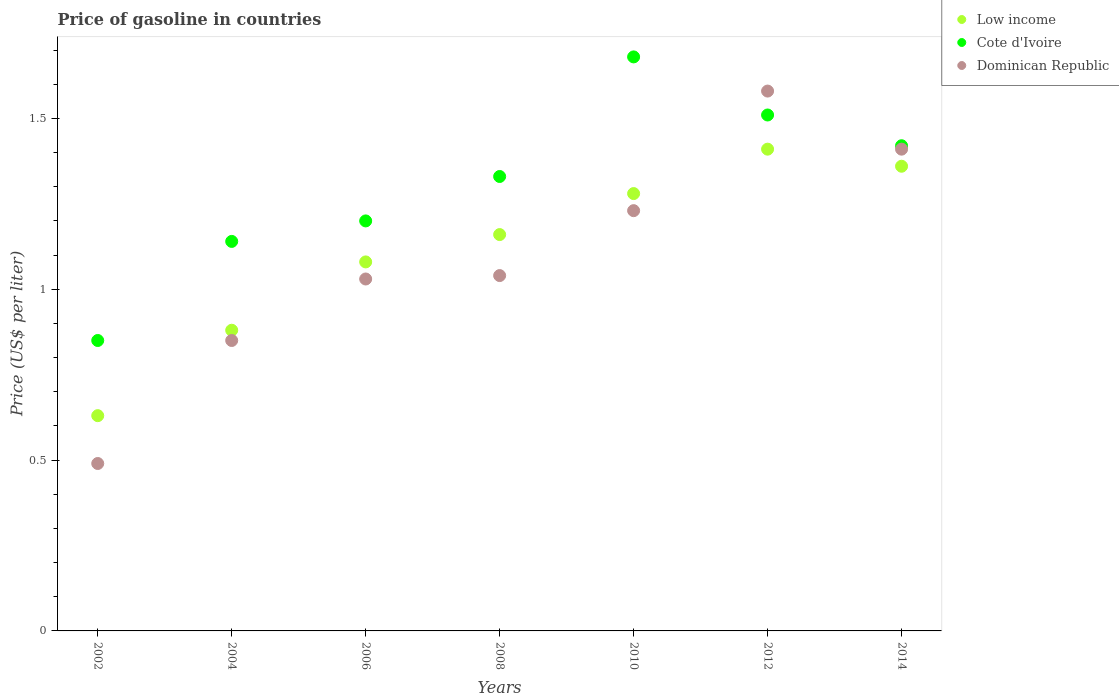What is the price of gasoline in Low income in 2012?
Ensure brevity in your answer.  1.41. Across all years, what is the maximum price of gasoline in Dominican Republic?
Offer a terse response. 1.58. Across all years, what is the minimum price of gasoline in Cote d'Ivoire?
Your response must be concise. 0.85. In which year was the price of gasoline in Dominican Republic minimum?
Keep it short and to the point. 2002. What is the total price of gasoline in Low income in the graph?
Ensure brevity in your answer.  7.8. What is the difference between the price of gasoline in Dominican Republic in 2006 and that in 2008?
Give a very brief answer. -0.01. What is the average price of gasoline in Low income per year?
Provide a succinct answer. 1.11. In the year 2008, what is the difference between the price of gasoline in Low income and price of gasoline in Cote d'Ivoire?
Keep it short and to the point. -0.17. In how many years, is the price of gasoline in Low income greater than 1.1 US$?
Offer a very short reply. 4. What is the ratio of the price of gasoline in Dominican Republic in 2004 to that in 2012?
Provide a short and direct response. 0.54. Is the difference between the price of gasoline in Low income in 2002 and 2014 greater than the difference between the price of gasoline in Cote d'Ivoire in 2002 and 2014?
Provide a short and direct response. No. What is the difference between the highest and the second highest price of gasoline in Dominican Republic?
Keep it short and to the point. 0.17. What is the difference between the highest and the lowest price of gasoline in Cote d'Ivoire?
Your response must be concise. 0.83. Is the sum of the price of gasoline in Low income in 2010 and 2014 greater than the maximum price of gasoline in Dominican Republic across all years?
Keep it short and to the point. Yes. Is it the case that in every year, the sum of the price of gasoline in Dominican Republic and price of gasoline in Cote d'Ivoire  is greater than the price of gasoline in Low income?
Make the answer very short. Yes. How many years are there in the graph?
Keep it short and to the point. 7. Does the graph contain grids?
Ensure brevity in your answer.  No. Where does the legend appear in the graph?
Ensure brevity in your answer.  Top right. How are the legend labels stacked?
Your answer should be compact. Vertical. What is the title of the graph?
Provide a short and direct response. Price of gasoline in countries. What is the label or title of the X-axis?
Your response must be concise. Years. What is the label or title of the Y-axis?
Your answer should be very brief. Price (US$ per liter). What is the Price (US$ per liter) in Low income in 2002?
Make the answer very short. 0.63. What is the Price (US$ per liter) of Cote d'Ivoire in 2002?
Provide a short and direct response. 0.85. What is the Price (US$ per liter) in Dominican Republic in 2002?
Give a very brief answer. 0.49. What is the Price (US$ per liter) in Cote d'Ivoire in 2004?
Provide a succinct answer. 1.14. What is the Price (US$ per liter) of Low income in 2006?
Your answer should be compact. 1.08. What is the Price (US$ per liter) of Dominican Republic in 2006?
Keep it short and to the point. 1.03. What is the Price (US$ per liter) in Low income in 2008?
Ensure brevity in your answer.  1.16. What is the Price (US$ per liter) of Cote d'Ivoire in 2008?
Your answer should be very brief. 1.33. What is the Price (US$ per liter) of Dominican Republic in 2008?
Provide a short and direct response. 1.04. What is the Price (US$ per liter) of Low income in 2010?
Offer a very short reply. 1.28. What is the Price (US$ per liter) in Cote d'Ivoire in 2010?
Your answer should be compact. 1.68. What is the Price (US$ per liter) in Dominican Republic in 2010?
Offer a very short reply. 1.23. What is the Price (US$ per liter) in Low income in 2012?
Offer a very short reply. 1.41. What is the Price (US$ per liter) in Cote d'Ivoire in 2012?
Offer a very short reply. 1.51. What is the Price (US$ per liter) in Dominican Republic in 2012?
Provide a succinct answer. 1.58. What is the Price (US$ per liter) in Low income in 2014?
Your answer should be compact. 1.36. What is the Price (US$ per liter) of Cote d'Ivoire in 2014?
Your response must be concise. 1.42. What is the Price (US$ per liter) of Dominican Republic in 2014?
Provide a short and direct response. 1.41. Across all years, what is the maximum Price (US$ per liter) in Low income?
Make the answer very short. 1.41. Across all years, what is the maximum Price (US$ per liter) in Cote d'Ivoire?
Provide a succinct answer. 1.68. Across all years, what is the maximum Price (US$ per liter) in Dominican Republic?
Provide a short and direct response. 1.58. Across all years, what is the minimum Price (US$ per liter) of Low income?
Your answer should be very brief. 0.63. Across all years, what is the minimum Price (US$ per liter) of Dominican Republic?
Ensure brevity in your answer.  0.49. What is the total Price (US$ per liter) of Cote d'Ivoire in the graph?
Your answer should be compact. 9.13. What is the total Price (US$ per liter) of Dominican Republic in the graph?
Ensure brevity in your answer.  7.63. What is the difference between the Price (US$ per liter) of Cote d'Ivoire in 2002 and that in 2004?
Give a very brief answer. -0.29. What is the difference between the Price (US$ per liter) of Dominican Republic in 2002 and that in 2004?
Your response must be concise. -0.36. What is the difference between the Price (US$ per liter) of Low income in 2002 and that in 2006?
Provide a succinct answer. -0.45. What is the difference between the Price (US$ per liter) of Cote d'Ivoire in 2002 and that in 2006?
Make the answer very short. -0.35. What is the difference between the Price (US$ per liter) of Dominican Republic in 2002 and that in 2006?
Your answer should be compact. -0.54. What is the difference between the Price (US$ per liter) in Low income in 2002 and that in 2008?
Offer a terse response. -0.53. What is the difference between the Price (US$ per liter) of Cote d'Ivoire in 2002 and that in 2008?
Your answer should be very brief. -0.48. What is the difference between the Price (US$ per liter) in Dominican Republic in 2002 and that in 2008?
Offer a terse response. -0.55. What is the difference between the Price (US$ per liter) in Low income in 2002 and that in 2010?
Offer a very short reply. -0.65. What is the difference between the Price (US$ per liter) of Cote d'Ivoire in 2002 and that in 2010?
Give a very brief answer. -0.83. What is the difference between the Price (US$ per liter) in Dominican Republic in 2002 and that in 2010?
Make the answer very short. -0.74. What is the difference between the Price (US$ per liter) in Low income in 2002 and that in 2012?
Offer a terse response. -0.78. What is the difference between the Price (US$ per liter) of Cote d'Ivoire in 2002 and that in 2012?
Offer a terse response. -0.66. What is the difference between the Price (US$ per liter) of Dominican Republic in 2002 and that in 2012?
Your answer should be compact. -1.09. What is the difference between the Price (US$ per liter) in Low income in 2002 and that in 2014?
Provide a succinct answer. -0.73. What is the difference between the Price (US$ per liter) in Cote d'Ivoire in 2002 and that in 2014?
Give a very brief answer. -0.57. What is the difference between the Price (US$ per liter) of Dominican Republic in 2002 and that in 2014?
Ensure brevity in your answer.  -0.92. What is the difference between the Price (US$ per liter) of Low income in 2004 and that in 2006?
Provide a short and direct response. -0.2. What is the difference between the Price (US$ per liter) of Cote d'Ivoire in 2004 and that in 2006?
Your response must be concise. -0.06. What is the difference between the Price (US$ per liter) of Dominican Republic in 2004 and that in 2006?
Provide a short and direct response. -0.18. What is the difference between the Price (US$ per liter) in Low income in 2004 and that in 2008?
Offer a very short reply. -0.28. What is the difference between the Price (US$ per liter) of Cote d'Ivoire in 2004 and that in 2008?
Your answer should be compact. -0.19. What is the difference between the Price (US$ per liter) in Dominican Republic in 2004 and that in 2008?
Provide a short and direct response. -0.19. What is the difference between the Price (US$ per liter) in Low income in 2004 and that in 2010?
Offer a very short reply. -0.4. What is the difference between the Price (US$ per liter) of Cote d'Ivoire in 2004 and that in 2010?
Give a very brief answer. -0.54. What is the difference between the Price (US$ per liter) in Dominican Republic in 2004 and that in 2010?
Offer a terse response. -0.38. What is the difference between the Price (US$ per liter) of Low income in 2004 and that in 2012?
Offer a terse response. -0.53. What is the difference between the Price (US$ per liter) in Cote d'Ivoire in 2004 and that in 2012?
Ensure brevity in your answer.  -0.37. What is the difference between the Price (US$ per liter) of Dominican Republic in 2004 and that in 2012?
Your answer should be very brief. -0.73. What is the difference between the Price (US$ per liter) of Low income in 2004 and that in 2014?
Give a very brief answer. -0.48. What is the difference between the Price (US$ per liter) in Cote d'Ivoire in 2004 and that in 2014?
Offer a very short reply. -0.28. What is the difference between the Price (US$ per liter) of Dominican Republic in 2004 and that in 2014?
Give a very brief answer. -0.56. What is the difference between the Price (US$ per liter) of Low income in 2006 and that in 2008?
Your answer should be compact. -0.08. What is the difference between the Price (US$ per liter) in Cote d'Ivoire in 2006 and that in 2008?
Offer a very short reply. -0.13. What is the difference between the Price (US$ per liter) in Dominican Republic in 2006 and that in 2008?
Offer a very short reply. -0.01. What is the difference between the Price (US$ per liter) in Low income in 2006 and that in 2010?
Make the answer very short. -0.2. What is the difference between the Price (US$ per liter) in Cote d'Ivoire in 2006 and that in 2010?
Your answer should be compact. -0.48. What is the difference between the Price (US$ per liter) of Dominican Republic in 2006 and that in 2010?
Give a very brief answer. -0.2. What is the difference between the Price (US$ per liter) of Low income in 2006 and that in 2012?
Give a very brief answer. -0.33. What is the difference between the Price (US$ per liter) in Cote d'Ivoire in 2006 and that in 2012?
Provide a short and direct response. -0.31. What is the difference between the Price (US$ per liter) of Dominican Republic in 2006 and that in 2012?
Ensure brevity in your answer.  -0.55. What is the difference between the Price (US$ per liter) of Low income in 2006 and that in 2014?
Offer a very short reply. -0.28. What is the difference between the Price (US$ per liter) in Cote d'Ivoire in 2006 and that in 2014?
Offer a very short reply. -0.22. What is the difference between the Price (US$ per liter) in Dominican Republic in 2006 and that in 2014?
Offer a very short reply. -0.38. What is the difference between the Price (US$ per liter) in Low income in 2008 and that in 2010?
Offer a very short reply. -0.12. What is the difference between the Price (US$ per liter) in Cote d'Ivoire in 2008 and that in 2010?
Your answer should be compact. -0.35. What is the difference between the Price (US$ per liter) in Dominican Republic in 2008 and that in 2010?
Your answer should be very brief. -0.19. What is the difference between the Price (US$ per liter) of Low income in 2008 and that in 2012?
Ensure brevity in your answer.  -0.25. What is the difference between the Price (US$ per liter) of Cote d'Ivoire in 2008 and that in 2012?
Your answer should be very brief. -0.18. What is the difference between the Price (US$ per liter) in Dominican Republic in 2008 and that in 2012?
Offer a terse response. -0.54. What is the difference between the Price (US$ per liter) in Cote d'Ivoire in 2008 and that in 2014?
Make the answer very short. -0.09. What is the difference between the Price (US$ per liter) of Dominican Republic in 2008 and that in 2014?
Give a very brief answer. -0.37. What is the difference between the Price (US$ per liter) of Low income in 2010 and that in 2012?
Provide a succinct answer. -0.13. What is the difference between the Price (US$ per liter) of Cote d'Ivoire in 2010 and that in 2012?
Make the answer very short. 0.17. What is the difference between the Price (US$ per liter) in Dominican Republic in 2010 and that in 2012?
Provide a succinct answer. -0.35. What is the difference between the Price (US$ per liter) in Low income in 2010 and that in 2014?
Ensure brevity in your answer.  -0.08. What is the difference between the Price (US$ per liter) in Cote d'Ivoire in 2010 and that in 2014?
Give a very brief answer. 0.26. What is the difference between the Price (US$ per liter) in Dominican Republic in 2010 and that in 2014?
Ensure brevity in your answer.  -0.18. What is the difference between the Price (US$ per liter) of Low income in 2012 and that in 2014?
Ensure brevity in your answer.  0.05. What is the difference between the Price (US$ per liter) in Cote d'Ivoire in 2012 and that in 2014?
Ensure brevity in your answer.  0.09. What is the difference between the Price (US$ per liter) of Dominican Republic in 2012 and that in 2014?
Ensure brevity in your answer.  0.17. What is the difference between the Price (US$ per liter) of Low income in 2002 and the Price (US$ per liter) of Cote d'Ivoire in 2004?
Provide a succinct answer. -0.51. What is the difference between the Price (US$ per liter) in Low income in 2002 and the Price (US$ per liter) in Dominican Republic in 2004?
Offer a very short reply. -0.22. What is the difference between the Price (US$ per liter) in Cote d'Ivoire in 2002 and the Price (US$ per liter) in Dominican Republic in 2004?
Your answer should be very brief. 0. What is the difference between the Price (US$ per liter) in Low income in 2002 and the Price (US$ per liter) in Cote d'Ivoire in 2006?
Give a very brief answer. -0.57. What is the difference between the Price (US$ per liter) of Cote d'Ivoire in 2002 and the Price (US$ per liter) of Dominican Republic in 2006?
Your answer should be compact. -0.18. What is the difference between the Price (US$ per liter) in Low income in 2002 and the Price (US$ per liter) in Cote d'Ivoire in 2008?
Give a very brief answer. -0.7. What is the difference between the Price (US$ per liter) in Low income in 2002 and the Price (US$ per liter) in Dominican Republic in 2008?
Offer a terse response. -0.41. What is the difference between the Price (US$ per liter) of Cote d'Ivoire in 2002 and the Price (US$ per liter) of Dominican Republic in 2008?
Provide a succinct answer. -0.19. What is the difference between the Price (US$ per liter) of Low income in 2002 and the Price (US$ per liter) of Cote d'Ivoire in 2010?
Your response must be concise. -1.05. What is the difference between the Price (US$ per liter) in Low income in 2002 and the Price (US$ per liter) in Dominican Republic in 2010?
Make the answer very short. -0.6. What is the difference between the Price (US$ per liter) of Cote d'Ivoire in 2002 and the Price (US$ per liter) of Dominican Republic in 2010?
Ensure brevity in your answer.  -0.38. What is the difference between the Price (US$ per liter) of Low income in 2002 and the Price (US$ per liter) of Cote d'Ivoire in 2012?
Provide a short and direct response. -0.88. What is the difference between the Price (US$ per liter) in Low income in 2002 and the Price (US$ per liter) in Dominican Republic in 2012?
Make the answer very short. -0.95. What is the difference between the Price (US$ per liter) in Cote d'Ivoire in 2002 and the Price (US$ per liter) in Dominican Republic in 2012?
Ensure brevity in your answer.  -0.73. What is the difference between the Price (US$ per liter) in Low income in 2002 and the Price (US$ per liter) in Cote d'Ivoire in 2014?
Offer a very short reply. -0.79. What is the difference between the Price (US$ per liter) in Low income in 2002 and the Price (US$ per liter) in Dominican Republic in 2014?
Your answer should be very brief. -0.78. What is the difference between the Price (US$ per liter) of Cote d'Ivoire in 2002 and the Price (US$ per liter) of Dominican Republic in 2014?
Give a very brief answer. -0.56. What is the difference between the Price (US$ per liter) of Low income in 2004 and the Price (US$ per liter) of Cote d'Ivoire in 2006?
Give a very brief answer. -0.32. What is the difference between the Price (US$ per liter) of Cote d'Ivoire in 2004 and the Price (US$ per liter) of Dominican Republic in 2006?
Offer a terse response. 0.11. What is the difference between the Price (US$ per liter) in Low income in 2004 and the Price (US$ per liter) in Cote d'Ivoire in 2008?
Your answer should be very brief. -0.45. What is the difference between the Price (US$ per liter) of Low income in 2004 and the Price (US$ per liter) of Dominican Republic in 2008?
Ensure brevity in your answer.  -0.16. What is the difference between the Price (US$ per liter) of Low income in 2004 and the Price (US$ per liter) of Cote d'Ivoire in 2010?
Provide a short and direct response. -0.8. What is the difference between the Price (US$ per liter) of Low income in 2004 and the Price (US$ per liter) of Dominican Republic in 2010?
Keep it short and to the point. -0.35. What is the difference between the Price (US$ per liter) of Cote d'Ivoire in 2004 and the Price (US$ per liter) of Dominican Republic in 2010?
Keep it short and to the point. -0.09. What is the difference between the Price (US$ per liter) of Low income in 2004 and the Price (US$ per liter) of Cote d'Ivoire in 2012?
Your answer should be compact. -0.63. What is the difference between the Price (US$ per liter) of Cote d'Ivoire in 2004 and the Price (US$ per liter) of Dominican Republic in 2012?
Provide a short and direct response. -0.44. What is the difference between the Price (US$ per liter) of Low income in 2004 and the Price (US$ per liter) of Cote d'Ivoire in 2014?
Keep it short and to the point. -0.54. What is the difference between the Price (US$ per liter) in Low income in 2004 and the Price (US$ per liter) in Dominican Republic in 2014?
Give a very brief answer. -0.53. What is the difference between the Price (US$ per liter) of Cote d'Ivoire in 2004 and the Price (US$ per liter) of Dominican Republic in 2014?
Your answer should be very brief. -0.27. What is the difference between the Price (US$ per liter) of Cote d'Ivoire in 2006 and the Price (US$ per liter) of Dominican Republic in 2008?
Ensure brevity in your answer.  0.16. What is the difference between the Price (US$ per liter) of Cote d'Ivoire in 2006 and the Price (US$ per liter) of Dominican Republic in 2010?
Offer a very short reply. -0.03. What is the difference between the Price (US$ per liter) in Low income in 2006 and the Price (US$ per liter) in Cote d'Ivoire in 2012?
Offer a terse response. -0.43. What is the difference between the Price (US$ per liter) of Cote d'Ivoire in 2006 and the Price (US$ per liter) of Dominican Republic in 2012?
Give a very brief answer. -0.38. What is the difference between the Price (US$ per liter) of Low income in 2006 and the Price (US$ per liter) of Cote d'Ivoire in 2014?
Give a very brief answer. -0.34. What is the difference between the Price (US$ per liter) of Low income in 2006 and the Price (US$ per liter) of Dominican Republic in 2014?
Offer a very short reply. -0.33. What is the difference between the Price (US$ per liter) of Cote d'Ivoire in 2006 and the Price (US$ per liter) of Dominican Republic in 2014?
Your answer should be compact. -0.21. What is the difference between the Price (US$ per liter) in Low income in 2008 and the Price (US$ per liter) in Cote d'Ivoire in 2010?
Your answer should be very brief. -0.52. What is the difference between the Price (US$ per liter) in Low income in 2008 and the Price (US$ per liter) in Dominican Republic in 2010?
Keep it short and to the point. -0.07. What is the difference between the Price (US$ per liter) of Cote d'Ivoire in 2008 and the Price (US$ per liter) of Dominican Republic in 2010?
Your response must be concise. 0.1. What is the difference between the Price (US$ per liter) of Low income in 2008 and the Price (US$ per liter) of Cote d'Ivoire in 2012?
Your response must be concise. -0.35. What is the difference between the Price (US$ per liter) in Low income in 2008 and the Price (US$ per liter) in Dominican Republic in 2012?
Your response must be concise. -0.42. What is the difference between the Price (US$ per liter) in Low income in 2008 and the Price (US$ per liter) in Cote d'Ivoire in 2014?
Your answer should be very brief. -0.26. What is the difference between the Price (US$ per liter) of Cote d'Ivoire in 2008 and the Price (US$ per liter) of Dominican Republic in 2014?
Give a very brief answer. -0.08. What is the difference between the Price (US$ per liter) in Low income in 2010 and the Price (US$ per liter) in Cote d'Ivoire in 2012?
Ensure brevity in your answer.  -0.23. What is the difference between the Price (US$ per liter) in Low income in 2010 and the Price (US$ per liter) in Dominican Republic in 2012?
Make the answer very short. -0.3. What is the difference between the Price (US$ per liter) of Low income in 2010 and the Price (US$ per liter) of Cote d'Ivoire in 2014?
Keep it short and to the point. -0.14. What is the difference between the Price (US$ per liter) in Low income in 2010 and the Price (US$ per liter) in Dominican Republic in 2014?
Give a very brief answer. -0.13. What is the difference between the Price (US$ per liter) of Cote d'Ivoire in 2010 and the Price (US$ per liter) of Dominican Republic in 2014?
Your answer should be very brief. 0.27. What is the difference between the Price (US$ per liter) of Low income in 2012 and the Price (US$ per liter) of Cote d'Ivoire in 2014?
Offer a terse response. -0.01. What is the difference between the Price (US$ per liter) of Cote d'Ivoire in 2012 and the Price (US$ per liter) of Dominican Republic in 2014?
Offer a terse response. 0.1. What is the average Price (US$ per liter) of Low income per year?
Offer a terse response. 1.11. What is the average Price (US$ per liter) of Cote d'Ivoire per year?
Keep it short and to the point. 1.3. What is the average Price (US$ per liter) in Dominican Republic per year?
Provide a succinct answer. 1.09. In the year 2002, what is the difference between the Price (US$ per liter) in Low income and Price (US$ per liter) in Cote d'Ivoire?
Make the answer very short. -0.22. In the year 2002, what is the difference between the Price (US$ per liter) of Low income and Price (US$ per liter) of Dominican Republic?
Give a very brief answer. 0.14. In the year 2002, what is the difference between the Price (US$ per liter) in Cote d'Ivoire and Price (US$ per liter) in Dominican Republic?
Your response must be concise. 0.36. In the year 2004, what is the difference between the Price (US$ per liter) of Low income and Price (US$ per liter) of Cote d'Ivoire?
Your response must be concise. -0.26. In the year 2004, what is the difference between the Price (US$ per liter) in Low income and Price (US$ per liter) in Dominican Republic?
Your response must be concise. 0.03. In the year 2004, what is the difference between the Price (US$ per liter) of Cote d'Ivoire and Price (US$ per liter) of Dominican Republic?
Offer a terse response. 0.29. In the year 2006, what is the difference between the Price (US$ per liter) of Low income and Price (US$ per liter) of Cote d'Ivoire?
Provide a succinct answer. -0.12. In the year 2006, what is the difference between the Price (US$ per liter) of Low income and Price (US$ per liter) of Dominican Republic?
Keep it short and to the point. 0.05. In the year 2006, what is the difference between the Price (US$ per liter) in Cote d'Ivoire and Price (US$ per liter) in Dominican Republic?
Your answer should be compact. 0.17. In the year 2008, what is the difference between the Price (US$ per liter) in Low income and Price (US$ per liter) in Cote d'Ivoire?
Give a very brief answer. -0.17. In the year 2008, what is the difference between the Price (US$ per liter) in Low income and Price (US$ per liter) in Dominican Republic?
Make the answer very short. 0.12. In the year 2008, what is the difference between the Price (US$ per liter) of Cote d'Ivoire and Price (US$ per liter) of Dominican Republic?
Offer a terse response. 0.29. In the year 2010, what is the difference between the Price (US$ per liter) of Low income and Price (US$ per liter) of Cote d'Ivoire?
Keep it short and to the point. -0.4. In the year 2010, what is the difference between the Price (US$ per liter) in Low income and Price (US$ per liter) in Dominican Republic?
Provide a short and direct response. 0.05. In the year 2010, what is the difference between the Price (US$ per liter) of Cote d'Ivoire and Price (US$ per liter) of Dominican Republic?
Give a very brief answer. 0.45. In the year 2012, what is the difference between the Price (US$ per liter) of Low income and Price (US$ per liter) of Dominican Republic?
Provide a succinct answer. -0.17. In the year 2012, what is the difference between the Price (US$ per liter) in Cote d'Ivoire and Price (US$ per liter) in Dominican Republic?
Offer a terse response. -0.07. In the year 2014, what is the difference between the Price (US$ per liter) of Low income and Price (US$ per liter) of Cote d'Ivoire?
Offer a terse response. -0.06. In the year 2014, what is the difference between the Price (US$ per liter) of Cote d'Ivoire and Price (US$ per liter) of Dominican Republic?
Your answer should be compact. 0.01. What is the ratio of the Price (US$ per liter) of Low income in 2002 to that in 2004?
Your answer should be very brief. 0.72. What is the ratio of the Price (US$ per liter) of Cote d'Ivoire in 2002 to that in 2004?
Provide a short and direct response. 0.75. What is the ratio of the Price (US$ per liter) in Dominican Republic in 2002 to that in 2004?
Keep it short and to the point. 0.58. What is the ratio of the Price (US$ per liter) in Low income in 2002 to that in 2006?
Keep it short and to the point. 0.58. What is the ratio of the Price (US$ per liter) of Cote d'Ivoire in 2002 to that in 2006?
Your answer should be very brief. 0.71. What is the ratio of the Price (US$ per liter) of Dominican Republic in 2002 to that in 2006?
Ensure brevity in your answer.  0.48. What is the ratio of the Price (US$ per liter) in Low income in 2002 to that in 2008?
Your answer should be compact. 0.54. What is the ratio of the Price (US$ per liter) of Cote d'Ivoire in 2002 to that in 2008?
Your response must be concise. 0.64. What is the ratio of the Price (US$ per liter) in Dominican Republic in 2002 to that in 2008?
Your answer should be very brief. 0.47. What is the ratio of the Price (US$ per liter) in Low income in 2002 to that in 2010?
Keep it short and to the point. 0.49. What is the ratio of the Price (US$ per liter) in Cote d'Ivoire in 2002 to that in 2010?
Provide a short and direct response. 0.51. What is the ratio of the Price (US$ per liter) in Dominican Republic in 2002 to that in 2010?
Make the answer very short. 0.4. What is the ratio of the Price (US$ per liter) in Low income in 2002 to that in 2012?
Provide a succinct answer. 0.45. What is the ratio of the Price (US$ per liter) in Cote d'Ivoire in 2002 to that in 2012?
Your response must be concise. 0.56. What is the ratio of the Price (US$ per liter) of Dominican Republic in 2002 to that in 2012?
Keep it short and to the point. 0.31. What is the ratio of the Price (US$ per liter) in Low income in 2002 to that in 2014?
Your answer should be compact. 0.46. What is the ratio of the Price (US$ per liter) of Cote d'Ivoire in 2002 to that in 2014?
Give a very brief answer. 0.6. What is the ratio of the Price (US$ per liter) in Dominican Republic in 2002 to that in 2014?
Your response must be concise. 0.35. What is the ratio of the Price (US$ per liter) in Low income in 2004 to that in 2006?
Provide a short and direct response. 0.81. What is the ratio of the Price (US$ per liter) of Dominican Republic in 2004 to that in 2006?
Make the answer very short. 0.83. What is the ratio of the Price (US$ per liter) in Low income in 2004 to that in 2008?
Provide a short and direct response. 0.76. What is the ratio of the Price (US$ per liter) of Dominican Republic in 2004 to that in 2008?
Your response must be concise. 0.82. What is the ratio of the Price (US$ per liter) in Low income in 2004 to that in 2010?
Your response must be concise. 0.69. What is the ratio of the Price (US$ per liter) in Cote d'Ivoire in 2004 to that in 2010?
Ensure brevity in your answer.  0.68. What is the ratio of the Price (US$ per liter) in Dominican Republic in 2004 to that in 2010?
Your response must be concise. 0.69. What is the ratio of the Price (US$ per liter) in Low income in 2004 to that in 2012?
Offer a terse response. 0.62. What is the ratio of the Price (US$ per liter) of Cote d'Ivoire in 2004 to that in 2012?
Provide a short and direct response. 0.76. What is the ratio of the Price (US$ per liter) in Dominican Republic in 2004 to that in 2012?
Your answer should be compact. 0.54. What is the ratio of the Price (US$ per liter) of Low income in 2004 to that in 2014?
Give a very brief answer. 0.65. What is the ratio of the Price (US$ per liter) in Cote d'Ivoire in 2004 to that in 2014?
Provide a short and direct response. 0.8. What is the ratio of the Price (US$ per liter) of Dominican Republic in 2004 to that in 2014?
Provide a succinct answer. 0.6. What is the ratio of the Price (US$ per liter) of Cote d'Ivoire in 2006 to that in 2008?
Your response must be concise. 0.9. What is the ratio of the Price (US$ per liter) of Low income in 2006 to that in 2010?
Provide a short and direct response. 0.84. What is the ratio of the Price (US$ per liter) of Cote d'Ivoire in 2006 to that in 2010?
Make the answer very short. 0.71. What is the ratio of the Price (US$ per liter) in Dominican Republic in 2006 to that in 2010?
Ensure brevity in your answer.  0.84. What is the ratio of the Price (US$ per liter) of Low income in 2006 to that in 2012?
Your answer should be compact. 0.77. What is the ratio of the Price (US$ per liter) of Cote d'Ivoire in 2006 to that in 2012?
Your answer should be compact. 0.79. What is the ratio of the Price (US$ per liter) in Dominican Republic in 2006 to that in 2012?
Keep it short and to the point. 0.65. What is the ratio of the Price (US$ per liter) in Low income in 2006 to that in 2014?
Your answer should be compact. 0.79. What is the ratio of the Price (US$ per liter) in Cote d'Ivoire in 2006 to that in 2014?
Your answer should be compact. 0.85. What is the ratio of the Price (US$ per liter) of Dominican Republic in 2006 to that in 2014?
Make the answer very short. 0.73. What is the ratio of the Price (US$ per liter) in Low income in 2008 to that in 2010?
Keep it short and to the point. 0.91. What is the ratio of the Price (US$ per liter) of Cote d'Ivoire in 2008 to that in 2010?
Provide a short and direct response. 0.79. What is the ratio of the Price (US$ per liter) in Dominican Republic in 2008 to that in 2010?
Offer a very short reply. 0.85. What is the ratio of the Price (US$ per liter) of Low income in 2008 to that in 2012?
Provide a short and direct response. 0.82. What is the ratio of the Price (US$ per liter) in Cote d'Ivoire in 2008 to that in 2012?
Keep it short and to the point. 0.88. What is the ratio of the Price (US$ per liter) in Dominican Republic in 2008 to that in 2012?
Ensure brevity in your answer.  0.66. What is the ratio of the Price (US$ per liter) in Low income in 2008 to that in 2014?
Make the answer very short. 0.85. What is the ratio of the Price (US$ per liter) of Cote d'Ivoire in 2008 to that in 2014?
Keep it short and to the point. 0.94. What is the ratio of the Price (US$ per liter) of Dominican Republic in 2008 to that in 2014?
Your response must be concise. 0.74. What is the ratio of the Price (US$ per liter) in Low income in 2010 to that in 2012?
Offer a terse response. 0.91. What is the ratio of the Price (US$ per liter) of Cote d'Ivoire in 2010 to that in 2012?
Give a very brief answer. 1.11. What is the ratio of the Price (US$ per liter) in Dominican Republic in 2010 to that in 2012?
Ensure brevity in your answer.  0.78. What is the ratio of the Price (US$ per liter) in Low income in 2010 to that in 2014?
Offer a very short reply. 0.94. What is the ratio of the Price (US$ per liter) of Cote d'Ivoire in 2010 to that in 2014?
Make the answer very short. 1.18. What is the ratio of the Price (US$ per liter) in Dominican Republic in 2010 to that in 2014?
Provide a succinct answer. 0.87. What is the ratio of the Price (US$ per liter) in Low income in 2012 to that in 2014?
Offer a very short reply. 1.04. What is the ratio of the Price (US$ per liter) in Cote d'Ivoire in 2012 to that in 2014?
Give a very brief answer. 1.06. What is the ratio of the Price (US$ per liter) of Dominican Republic in 2012 to that in 2014?
Your response must be concise. 1.12. What is the difference between the highest and the second highest Price (US$ per liter) in Cote d'Ivoire?
Offer a terse response. 0.17. What is the difference between the highest and the second highest Price (US$ per liter) in Dominican Republic?
Make the answer very short. 0.17. What is the difference between the highest and the lowest Price (US$ per liter) of Low income?
Your answer should be very brief. 0.78. What is the difference between the highest and the lowest Price (US$ per liter) of Cote d'Ivoire?
Your answer should be very brief. 0.83. What is the difference between the highest and the lowest Price (US$ per liter) of Dominican Republic?
Offer a terse response. 1.09. 